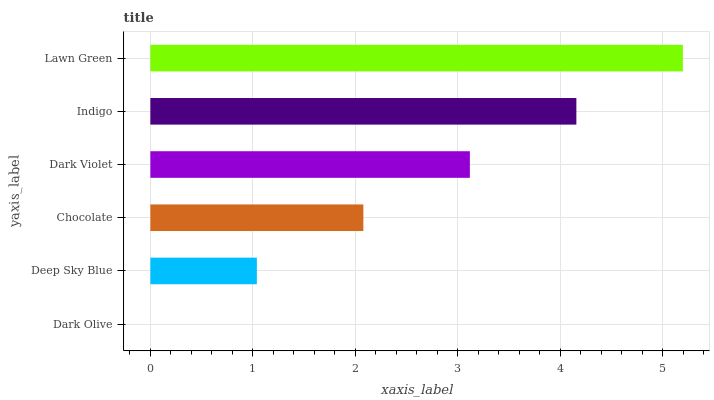Is Dark Olive the minimum?
Answer yes or no. Yes. Is Lawn Green the maximum?
Answer yes or no. Yes. Is Deep Sky Blue the minimum?
Answer yes or no. No. Is Deep Sky Blue the maximum?
Answer yes or no. No. Is Deep Sky Blue greater than Dark Olive?
Answer yes or no. Yes. Is Dark Olive less than Deep Sky Blue?
Answer yes or no. Yes. Is Dark Olive greater than Deep Sky Blue?
Answer yes or no. No. Is Deep Sky Blue less than Dark Olive?
Answer yes or no. No. Is Dark Violet the high median?
Answer yes or no. Yes. Is Chocolate the low median?
Answer yes or no. Yes. Is Chocolate the high median?
Answer yes or no. No. Is Lawn Green the low median?
Answer yes or no. No. 